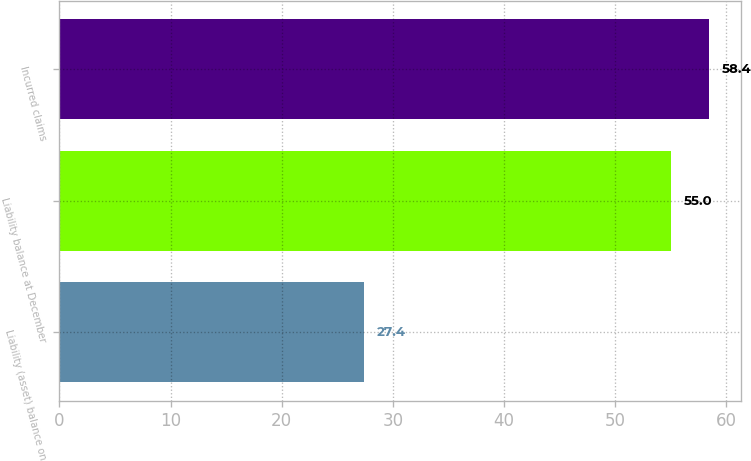<chart> <loc_0><loc_0><loc_500><loc_500><bar_chart><fcel>Liability (asset) balance on<fcel>Liability balance at December<fcel>Incurred claims<nl><fcel>27.4<fcel>55<fcel>58.4<nl></chart> 